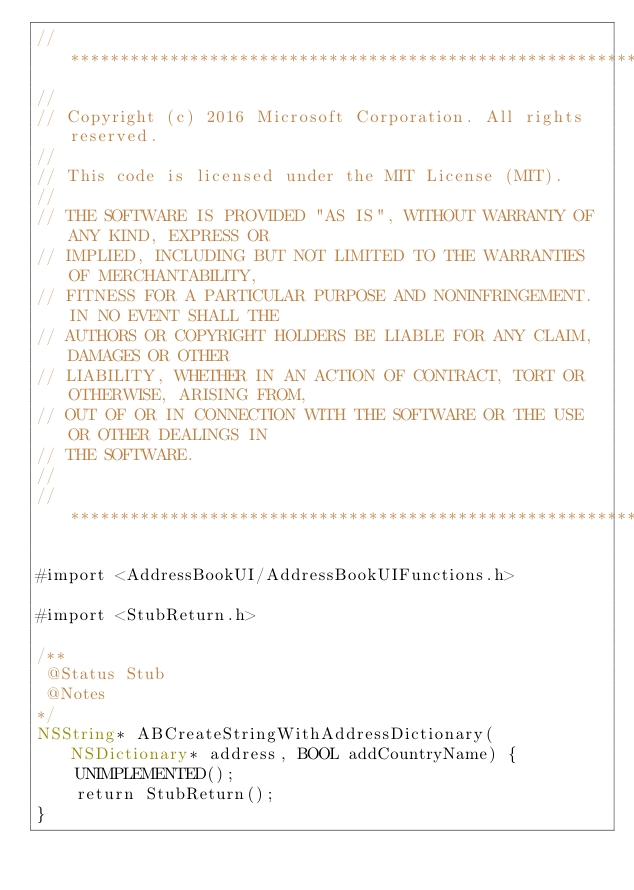Convert code to text. <code><loc_0><loc_0><loc_500><loc_500><_ObjectiveC_>//******************************************************************************
//
// Copyright (c) 2016 Microsoft Corporation. All rights reserved.
//
// This code is licensed under the MIT License (MIT).
//
// THE SOFTWARE IS PROVIDED "AS IS", WITHOUT WARRANTY OF ANY KIND, EXPRESS OR
// IMPLIED, INCLUDING BUT NOT LIMITED TO THE WARRANTIES OF MERCHANTABILITY,
// FITNESS FOR A PARTICULAR PURPOSE AND NONINFRINGEMENT. IN NO EVENT SHALL THE
// AUTHORS OR COPYRIGHT HOLDERS BE LIABLE FOR ANY CLAIM, DAMAGES OR OTHER
// LIABILITY, WHETHER IN AN ACTION OF CONTRACT, TORT OR OTHERWISE, ARISING FROM,
// OUT OF OR IN CONNECTION WITH THE SOFTWARE OR THE USE OR OTHER DEALINGS IN
// THE SOFTWARE.
//
//******************************************************************************

#import <AddressBookUI/AddressBookUIFunctions.h>

#import <StubReturn.h>

/**
 @Status Stub
 @Notes
*/
NSString* ABCreateStringWithAddressDictionary(NSDictionary* address, BOOL addCountryName) {
    UNIMPLEMENTED();
    return StubReturn();
}
</code> 